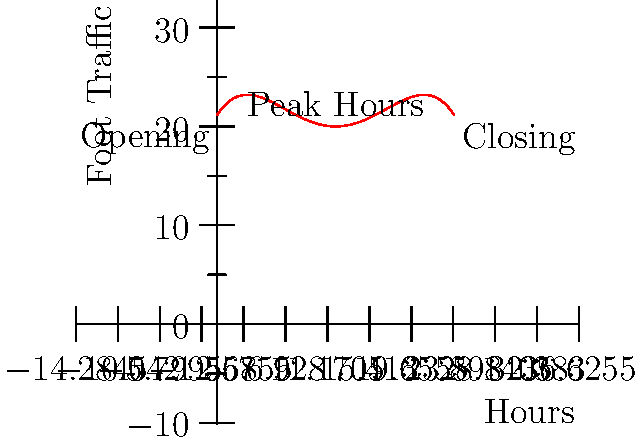The graph above represents the foot traffic in your boutique shop throughout a typical day using a quartic polynomial. The x-axis represents the hours of the day (0-24), and the y-axis represents the number of customers in the store. Based on this graph, during which 2-hour period would you recommend scheduling an extra staff member to handle the increased customer flow? To determine the best 2-hour period for extra staffing, we need to identify the peak foot traffic time:

1. The graph is symmetrical, with the peak occurring at the vertex of the quartic function.
2. The vertex is clearly at x = 12, which corresponds to 12:00 PM (noon).
3. To find the best 2-hour window, we should center it around the peak:
   - Start time: 12:00 PM - 1 hour = 11:00 AM
   - End time: 12:00 PM + 1 hour = 1:00 PM
4. This 2-hour window (11:00 AM to 1:00 PM) captures the highest point of the curve and the steepest slopes on either side, indicating the busiest period.
5. Scheduling an extra staff member during this time would help manage the increased customer flow most effectively.
Answer: 11:00 AM to 1:00 PM 